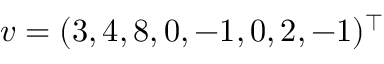<formula> <loc_0><loc_0><loc_500><loc_500>v = ( 3 , 4 , 8 , 0 , - 1 , 0 , 2 , - 1 ) ^ { \top }</formula> 